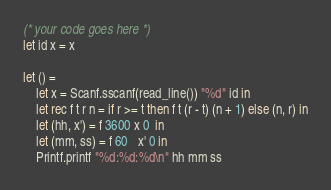<code> <loc_0><loc_0><loc_500><loc_500><_OCaml_>(* your code goes here *)
let id x = x

let () =
    let x = Scanf.sscanf(read_line()) "%d" id in
    let rec f t r n = if r >= t then f t (r - t) (n + 1) else (n, r) in
    let (hh, x') = f 3600 x 0  in
    let (mm, ss) = f 60   x' 0 in
    Printf.printf "%d:%d:%d\n" hh mm ss
</code> 